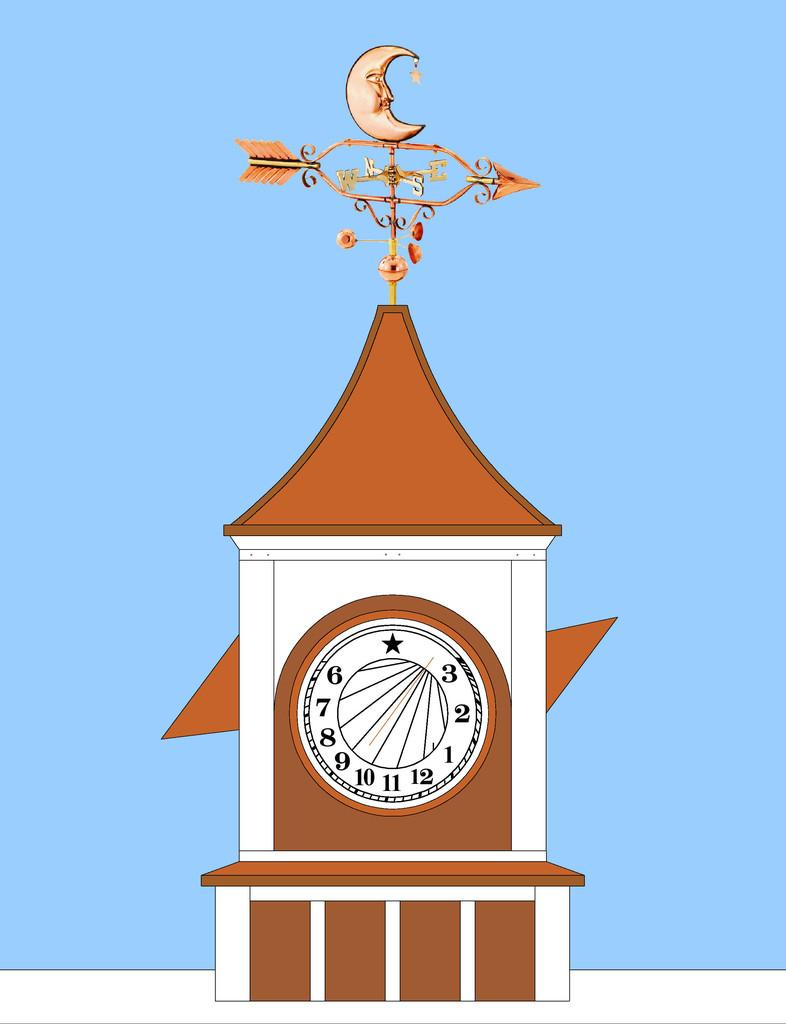<image>
Share a concise interpretation of the image provided. A clock with a star in the place of where the 12 would normally be. 